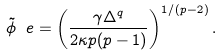Convert formula to latex. <formula><loc_0><loc_0><loc_500><loc_500>\tilde { \phi } _ { \ } e = \left ( \frac { \gamma \Delta ^ { q } } { 2 \kappa p ( p - 1 ) } \right ) ^ { 1 / ( p - 2 ) } .</formula> 